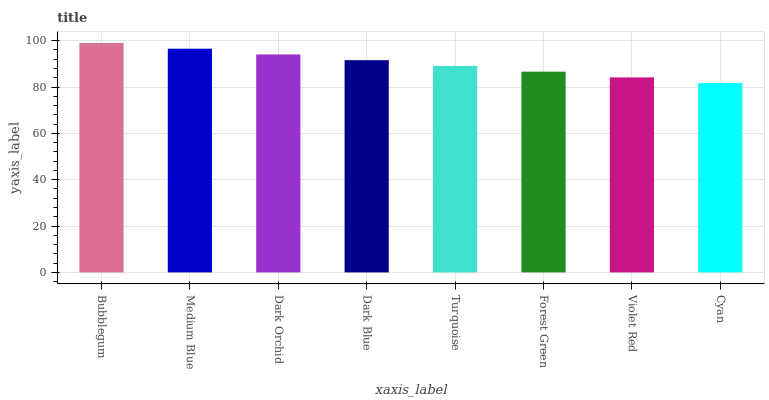Is Cyan the minimum?
Answer yes or no. Yes. Is Bubblegum the maximum?
Answer yes or no. Yes. Is Medium Blue the minimum?
Answer yes or no. No. Is Medium Blue the maximum?
Answer yes or no. No. Is Bubblegum greater than Medium Blue?
Answer yes or no. Yes. Is Medium Blue less than Bubblegum?
Answer yes or no. Yes. Is Medium Blue greater than Bubblegum?
Answer yes or no. No. Is Bubblegum less than Medium Blue?
Answer yes or no. No. Is Dark Blue the high median?
Answer yes or no. Yes. Is Turquoise the low median?
Answer yes or no. Yes. Is Dark Orchid the high median?
Answer yes or no. No. Is Dark Orchid the low median?
Answer yes or no. No. 